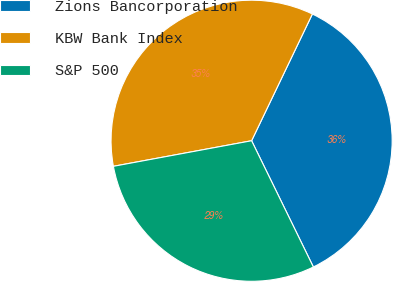<chart> <loc_0><loc_0><loc_500><loc_500><pie_chart><fcel>Zions Bancorporation<fcel>KBW Bank Index<fcel>S&P 500<nl><fcel>35.64%<fcel>35.03%<fcel>29.33%<nl></chart> 